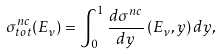<formula> <loc_0><loc_0><loc_500><loc_500>\sigma _ { t o t } ^ { n c } ( E _ { \nu } ) = \int _ { 0 } ^ { 1 } \frac { d \sigma ^ { n c } } { d y } \, ( E _ { \nu } , y ) \, d y ,</formula> 